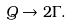<formula> <loc_0><loc_0><loc_500><loc_500>Q \to 2 \Gamma .</formula> 